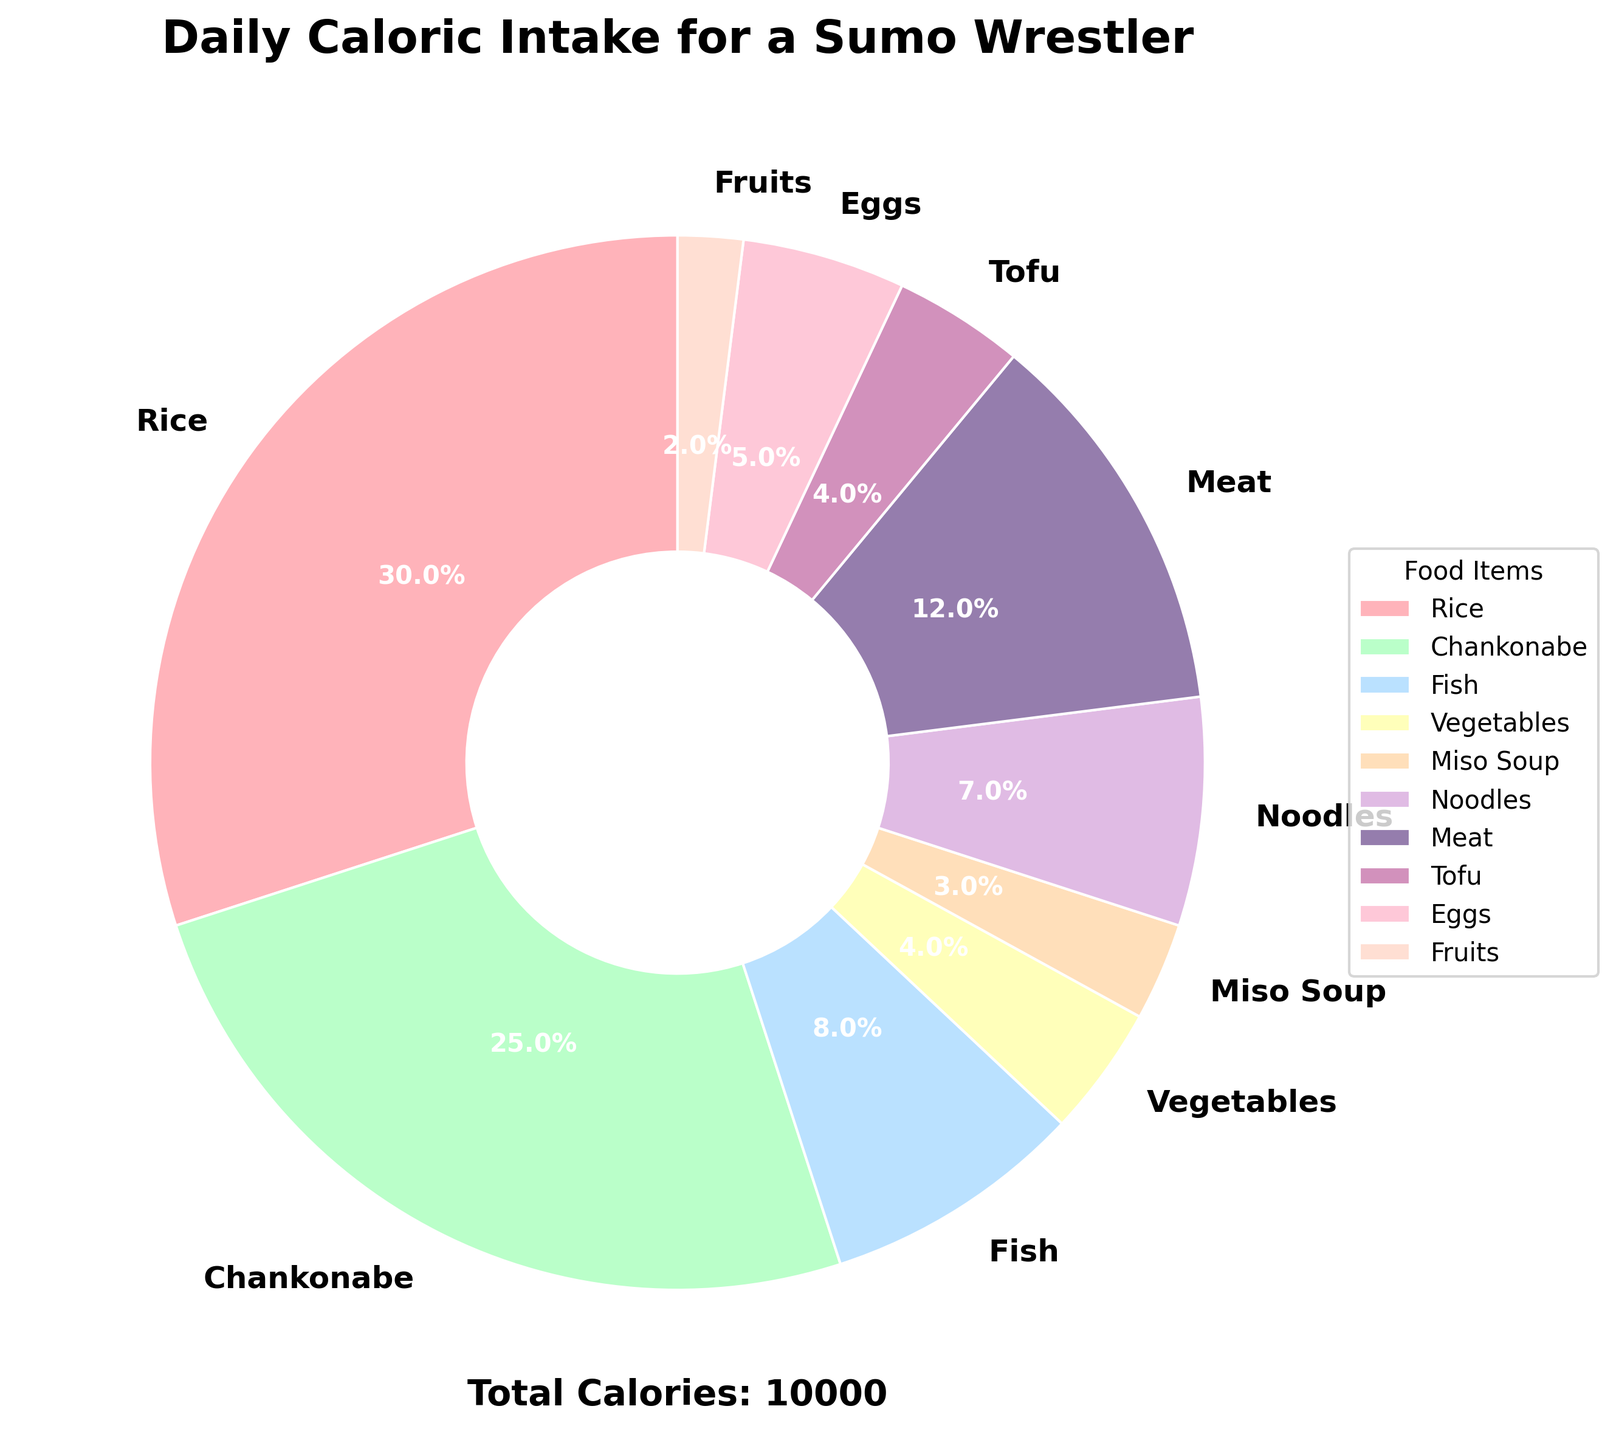How many calories come from rice and chankonabe combined? Combine the calories from rice (3000) and chankonabe (2500). The total is 3000 + 2500 = 5500 calories.
Answer: 5500 Which food item contributes the least to the caloric intake? By looking at the pie chart, fruits have the smallest section, indicating the least calorie contribution of 200 calories.
Answer: Fruits Does meat or noodles contribute more calories to the sumo wrestler's diet? Compare the calories from meat (1200) and noodles (700). Meat contributes more calories.
Answer: Meat What is the total caloric intake from miso soup, tofu, and eggs combined? Sum the calories from miso soup (300), tofu (400), and eggs (500). The total is 300 + 400 + 500 = 1200 calories.
Answer: 1200 What percentage of the total daily caloric intake does fish contribute? From the pie chart, fish contributes 800 calories. Calculate the percentage: (800 / 9000) * 100 ≈ 8.9%.
Answer: 8.9% Which food item contributes more calories, rice or all of the vegetables combined with tofu? Rice contributes 3000 calories. Vegetables (400) + tofu (400) = 800. Rice contributes more calories.
Answer: Rice What is the difference in calories between the highest and lowest contributing food items? The highest is rice (3000) and the lowest is fruits (200). The difference is 3000 - 200 = 2800 calories.
Answer: 2800 What fraction of the daily caloric intake comes from rice? Rice contributes 3000 out of 9000 total calories. The fraction is 3000/9000 = 1/3.
Answer: 1/3 Is the sum of the calories from chankonabe and meat greater than the sum of the calories from fish, vegetables, and noodles? Chankonabe (2500) + meat (1200) = 3700. Fish (800) + vegetables (400) + noodles (700) = 1900. 3700 is greater than 1900.
Answer: Yes What is the average caloric intake per food item? Sum all the values (9000) and divide by the number of food items (10). The average is 9000/10 = 900 calories per food item.
Answer: 900 